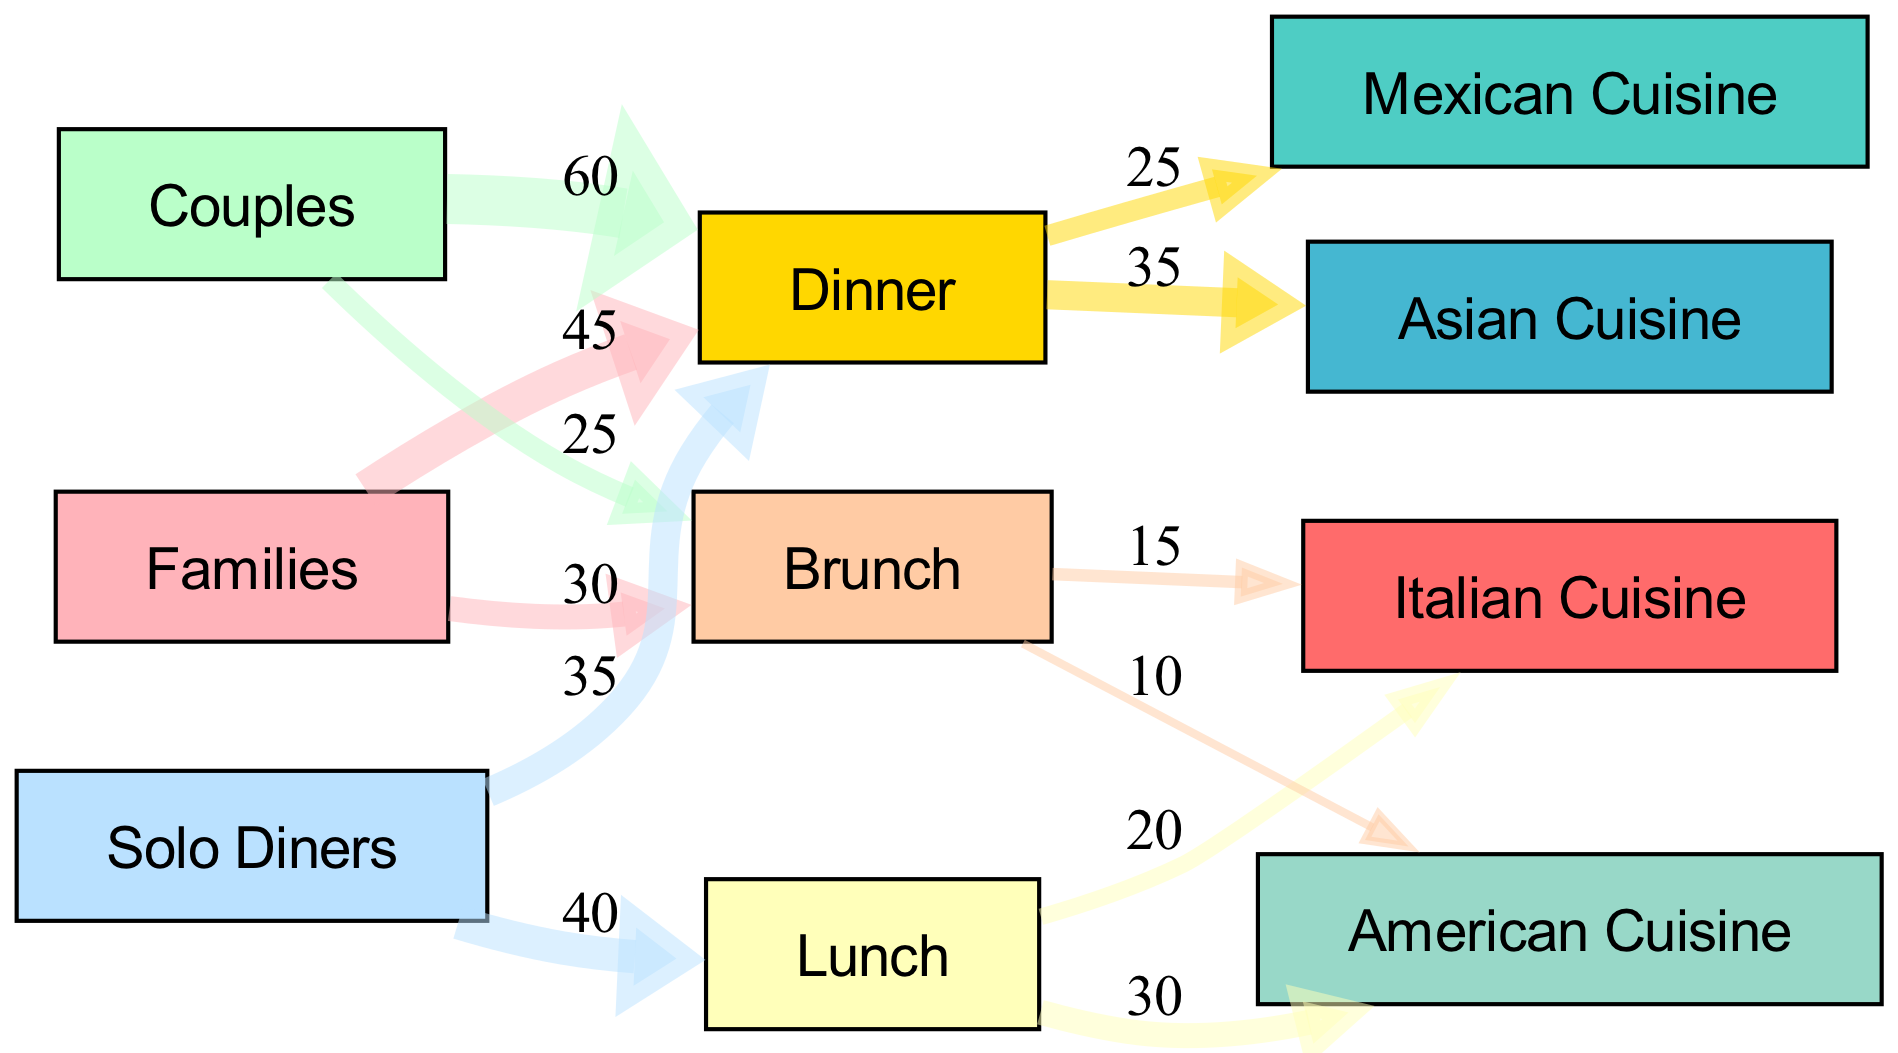What is the total number of nodes in the diagram? The diagram includes a total of 10 nodes, which represent different customer types, dining times, and cuisine preferences.
Answer: 10 Which customer type has the highest flow to Dinner? Couples have the highest flow to Dinner with a value of 60. You can see this directly on the diagram as they have the thickest line connecting to the Dinner node.
Answer: Couples How many families prefer Brunch? Families show a preference for Brunch with a flow value of 30. This value can be observed by checking the link from the Families node to the Brunch node.
Answer: 30 What is the flow of Solo Diners to Lunch? The flow of Solo Diners to Lunch is 40. By looking at the connection from the Solo Diners node to the Lunch node, the value is displayed clearly as 40.
Answer: 40 Which cuisine is preferred most at Dinner? Asian cuisine is preferred most at Dinner, showing a higher flow value of 35 compared to Mexican, which has a flow of 25. This can be seen in the two links branching from the Dinner node.
Answer: Asian How many customers in total prefer Lunch? To determine the total for Lunch, you need to sum the flow from Solo Diners and the Lunch node connections: Solo Diners (40) plus the preferences at Lunch (20 for Italian and 30 for American). The total equals 40 + 20 + 30 = 90.
Answer: 90 Which type of customer has the least connection to Brunch? The customer type with the least connection to Brunch is Solo Diners, as they do not have any direct links to Brunch in the diagram.
Answer: Solo Diners What percentage of Families prefer Dinner compared to their total preferences? Families have a flow of 45 for Dinner and 30 for Brunch, resulting in a total of 45 + 30 = 75. The percentage for Dinner is (45/75)*100, which equals 60%.
Answer: 60% Which dining time has the lowest total flow across all customer types? Lunch has the lowest total flow when you sum up preferences: 40 from Solo Diners, 20 from Italian, and 30 from American for a total of 90, which is less than Dinner (100) and Brunch (55).
Answer: Lunch 